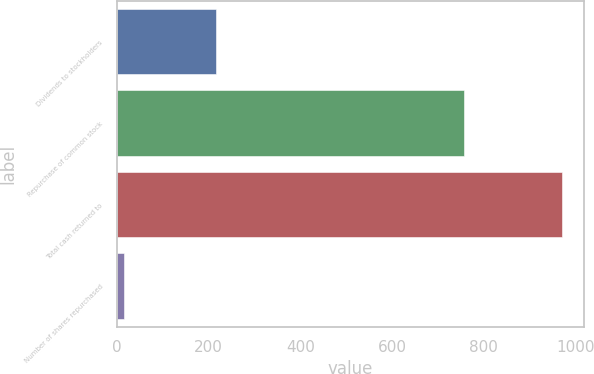Convert chart. <chart><loc_0><loc_0><loc_500><loc_500><bar_chart><fcel>Dividends to stockholders<fcel>Repurchase of common stock<fcel>Total cash returned to<fcel>Number of shares repurchased<nl><fcel>214.7<fcel>755.8<fcel>970.5<fcel>14.5<nl></chart> 